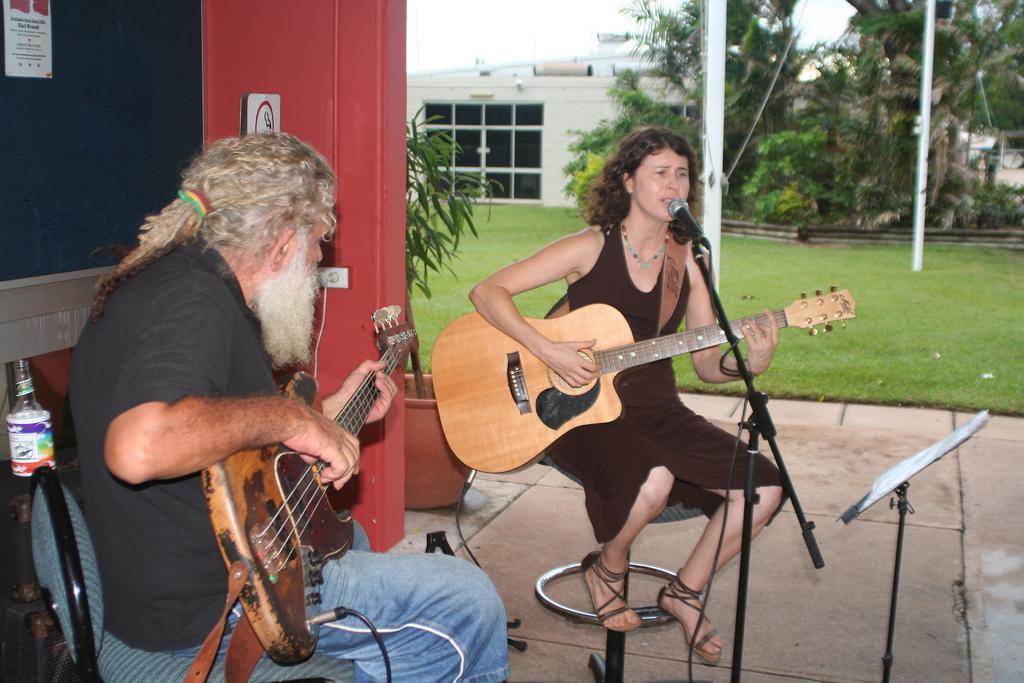Describe this image in one or two sentences. There is a woman sitting on the chair. she is singing a song and playing guitar. I can see another man sitting on the chair and playing guitar. At background I can see building with glass doors. These are the trees and Plants. This is a mike with the mike stand. At the left corner of the image I can see bottle kept on the table. This is a small plant which is planted on the flower pot. This is a pillar with white color. 